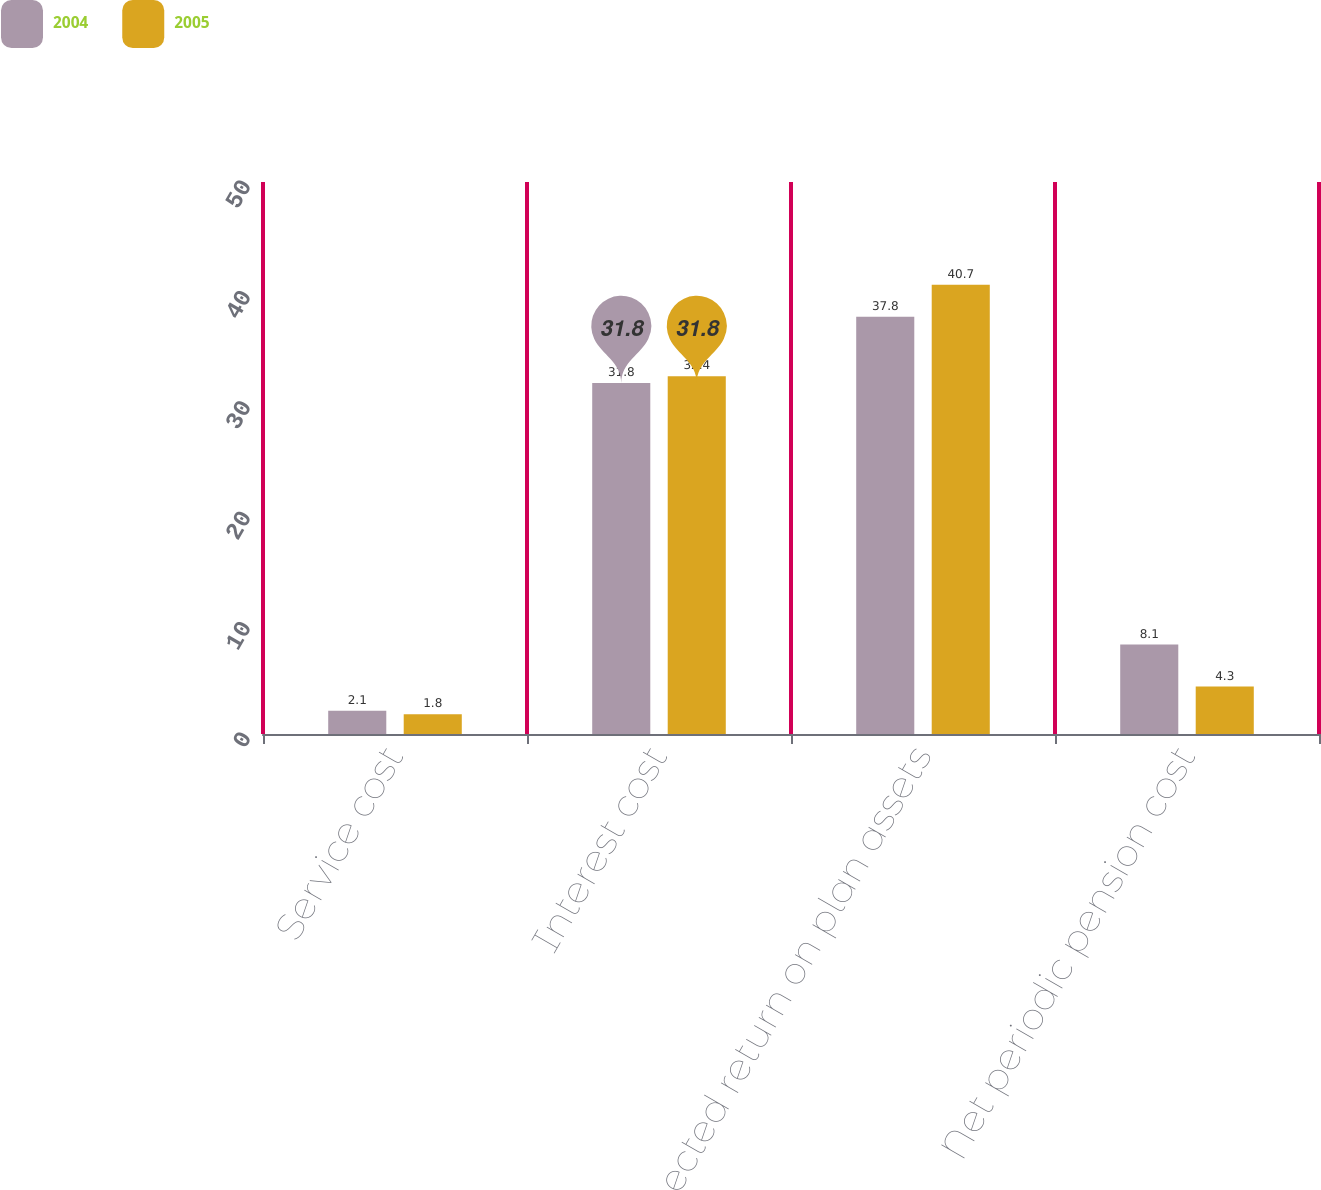<chart> <loc_0><loc_0><loc_500><loc_500><stacked_bar_chart><ecel><fcel>Service cost<fcel>Interest cost<fcel>Expected return on plan assets<fcel>Net periodic pension cost<nl><fcel>2004<fcel>2.1<fcel>31.8<fcel>37.8<fcel>8.1<nl><fcel>2005<fcel>1.8<fcel>32.4<fcel>40.7<fcel>4.3<nl></chart> 